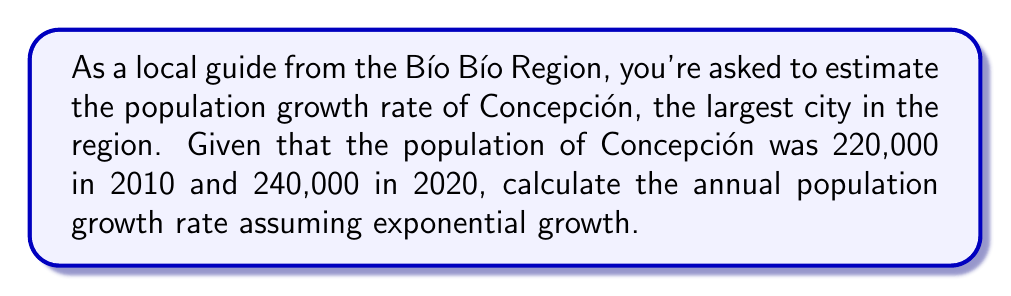Provide a solution to this math problem. To calculate the annual population growth rate assuming exponential growth, we can use the following formula:

$$ P_t = P_0 \cdot e^{rt} $$

Where:
$P_t$ is the final population
$P_0$ is the initial population
$r$ is the annual growth rate
$t$ is the time period in years

Given:
$P_0 = 220,000$ (population in 2010)
$P_t = 240,000$ (population in 2020)
$t = 10$ years

Let's solve for $r$:

1) Substitute the values into the formula:
   $$ 240,000 = 220,000 \cdot e^{10r} $$

2) Divide both sides by 220,000:
   $$ \frac{240,000}{220,000} = e^{10r} $$

3) Simplify:
   $$ 1.0909 = e^{10r} $$

4) Take the natural logarithm of both sides:
   $$ \ln(1.0909) = \ln(e^{10r}) $$

5) Simplify the right side:
   $$ \ln(1.0909) = 10r $$

6) Solve for $r$:
   $$ r = \frac{\ln(1.0909)}{10} $$

7) Calculate:
   $$ r = 0.00869 $$

8) Convert to percentage:
   $$ r = 0.00869 \cdot 100\% = 0.869\% $$

Therefore, the annual population growth rate of Concepción between 2010 and 2020 was approximately 0.869%.
Answer: The annual population growth rate of Concepción between 2010 and 2020 was approximately 0.869%. 